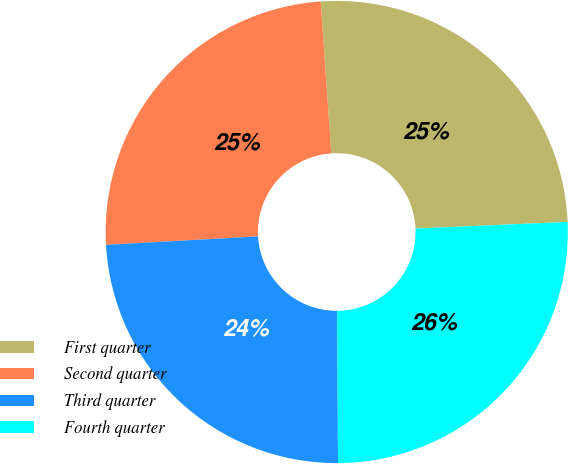<chart> <loc_0><loc_0><loc_500><loc_500><pie_chart><fcel>First quarter<fcel>Second quarter<fcel>Third quarter<fcel>Fourth quarter<nl><fcel>25.41%<fcel>24.78%<fcel>24.2%<fcel>25.61%<nl></chart> 